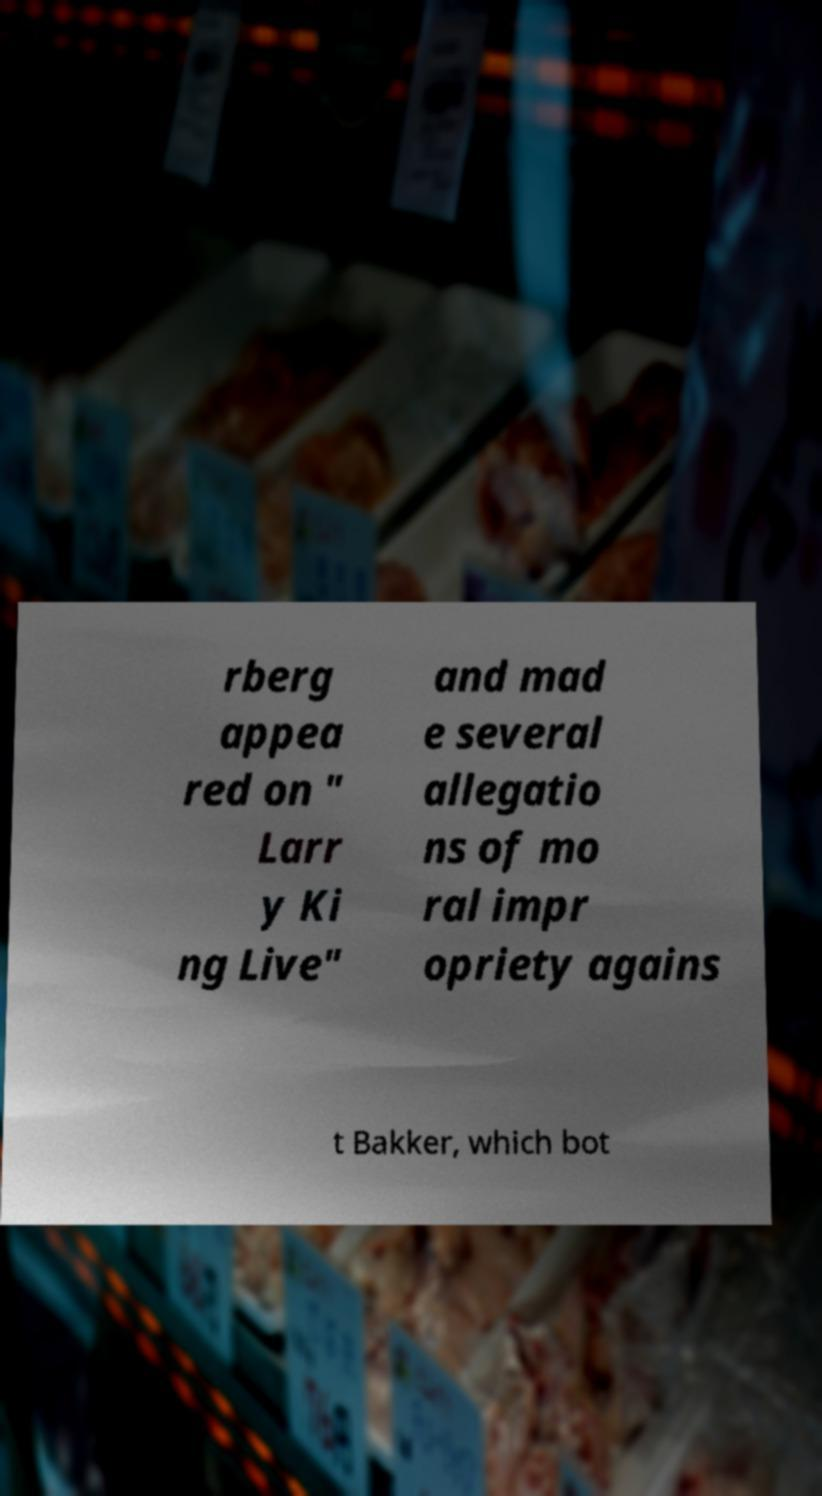Please read and relay the text visible in this image. What does it say? rberg appea red on " Larr y Ki ng Live" and mad e several allegatio ns of mo ral impr opriety agains t Bakker, which bot 